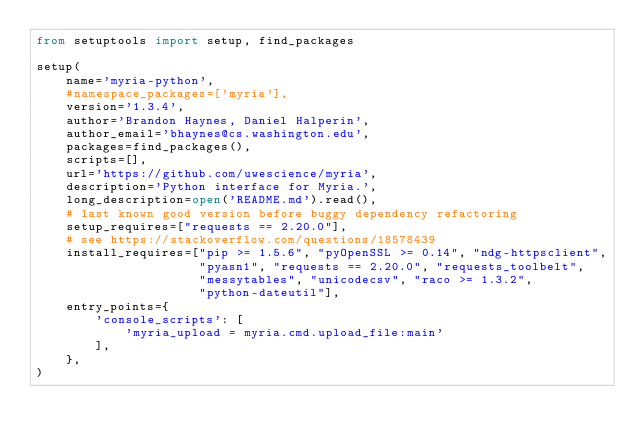Convert code to text. <code><loc_0><loc_0><loc_500><loc_500><_Python_>from setuptools import setup, find_packages

setup(
    name='myria-python',
    #namespace_packages=['myria'],
    version='1.3.4',
    author='Brandon Haynes, Daniel Halperin',
    author_email='bhaynes@cs.washington.edu',
    packages=find_packages(),
    scripts=[],
    url='https://github.com/uwescience/myria',
    description='Python interface for Myria.',
    long_description=open('README.md').read(),
    # last known good version before buggy dependency refactoring
    setup_requires=["requests == 2.20.0"],
    # see https://stackoverflow.com/questions/18578439
    install_requires=["pip >= 1.5.6", "pyOpenSSL >= 0.14", "ndg-httpsclient",
                      "pyasn1", "requests == 2.20.0", "requests_toolbelt",
                      "messytables", "unicodecsv", "raco >= 1.3.2",
                      "python-dateutil"],
    entry_points={
        'console_scripts': [
            'myria_upload = myria.cmd.upload_file:main'
        ],
    },
)
</code> 